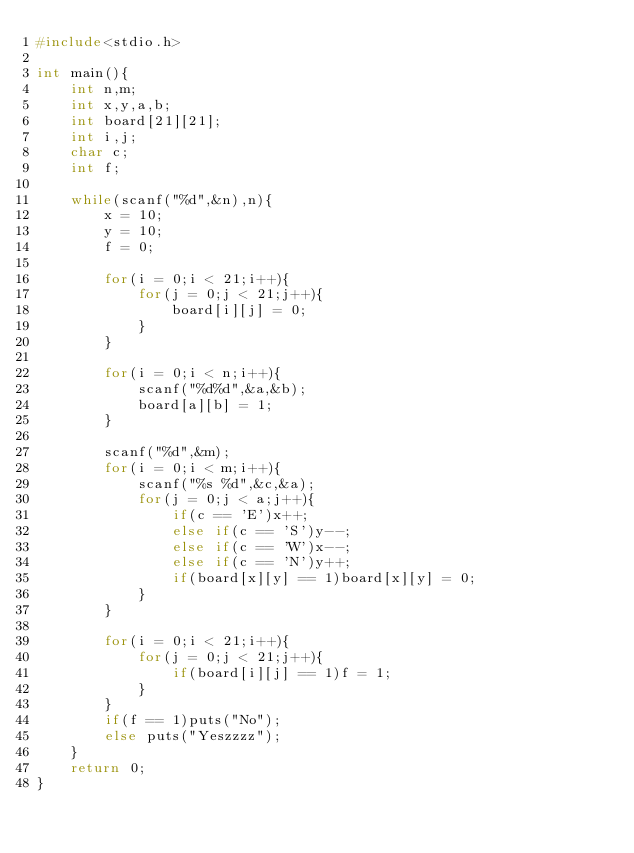<code> <loc_0><loc_0><loc_500><loc_500><_C_>#include<stdio.h>

int main(){
	int n,m;
	int x,y,a,b;
	int board[21][21];
	int i,j;
	char c;
	int f;

	while(scanf("%d",&n),n){
		x = 10;
		y = 10;
		f = 0;
		
		for(i = 0;i < 21;i++){
			for(j = 0;j < 21;j++){
				board[i][j] = 0;
			}
		}
		
		for(i = 0;i < n;i++){
			scanf("%d%d",&a,&b);
			board[a][b] = 1;
		}

		scanf("%d",&m);
		for(i = 0;i < m;i++){
			scanf("%s %d",&c,&a);
			for(j = 0;j < a;j++){
				if(c == 'E')x++;
				else if(c == 'S')y--;
				else if(c == 'W')x--;
				else if(c == 'N')y++;
				if(board[x][y] == 1)board[x][y] = 0;
			}
		}

		for(i = 0;i < 21;i++){
			for(j = 0;j < 21;j++){
				if(board[i][j] == 1)f = 1;
			}
		}
		if(f == 1)puts("No");
		else puts("Yeszzzz");
	}
	return 0;
}

				</code> 